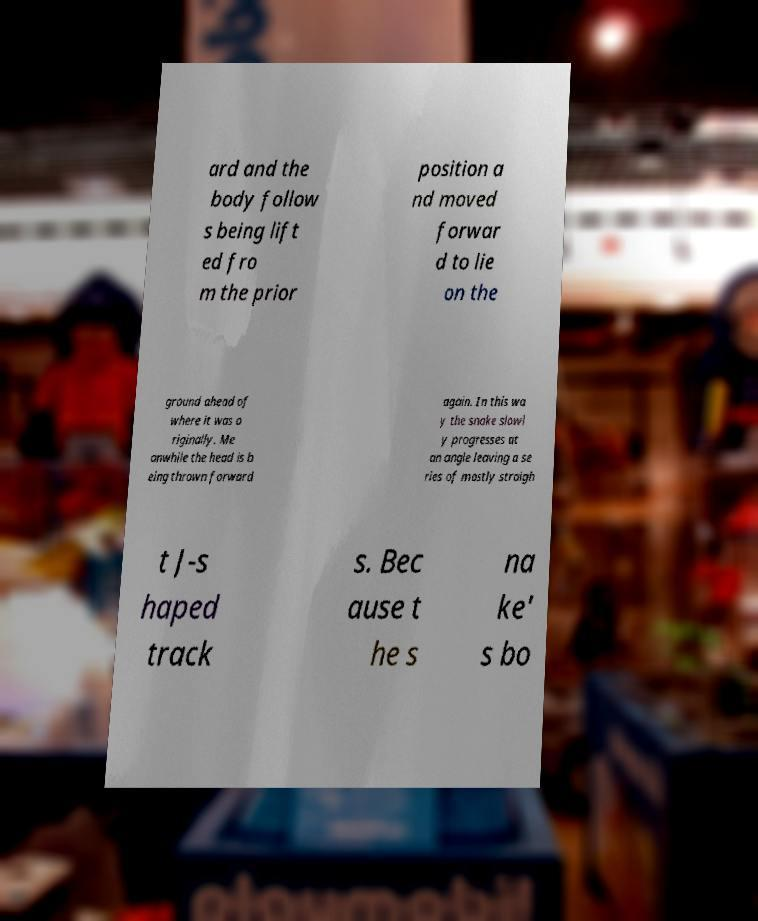Can you read and provide the text displayed in the image?This photo seems to have some interesting text. Can you extract and type it out for me? ard and the body follow s being lift ed fro m the prior position a nd moved forwar d to lie on the ground ahead of where it was o riginally. Me anwhile the head is b eing thrown forward again. In this wa y the snake slowl y progresses at an angle leaving a se ries of mostly straigh t J-s haped track s. Bec ause t he s na ke' s bo 